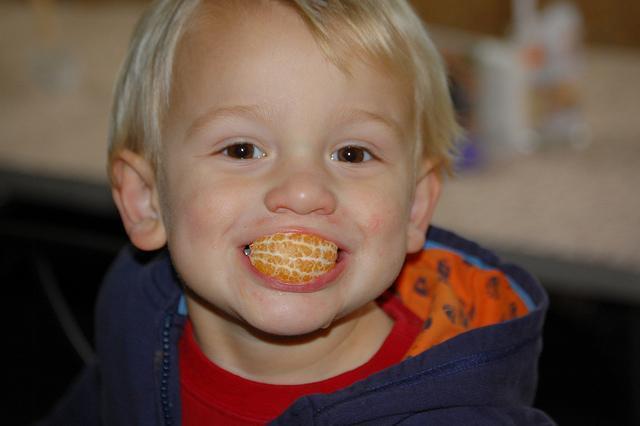How many cats are meowing on a bed?
Give a very brief answer. 0. 